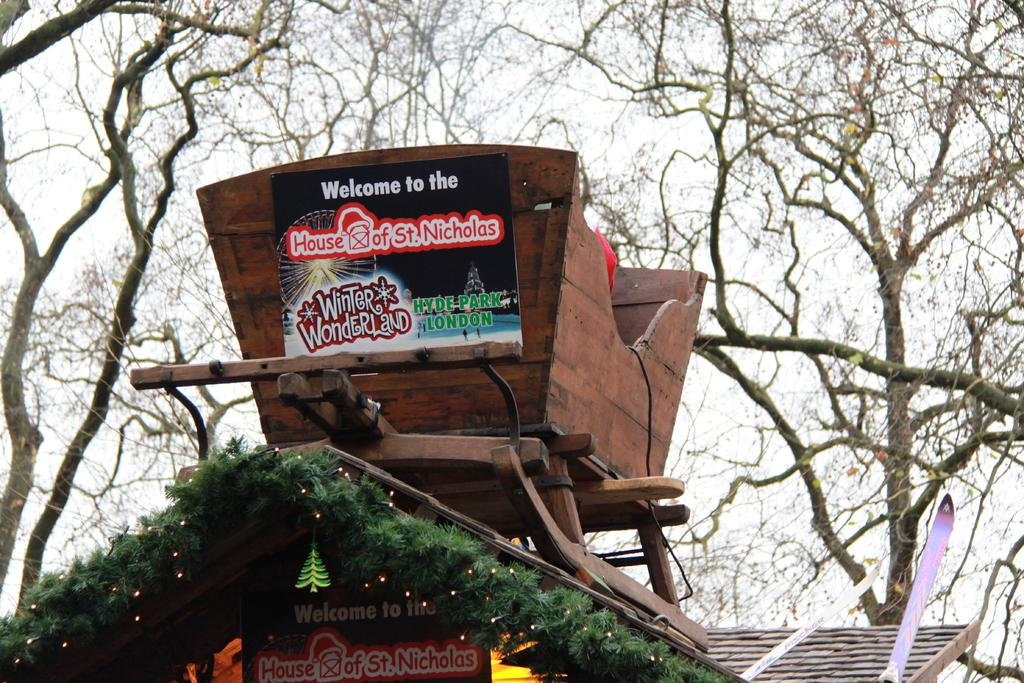What type of house is in the image? There is a wooden house in the image. What material is the house made of? The wooden house has boards. Is there any writing or text on the house? Yes, there is text on the boards of the wooden house. What can be seen in the background of the image? There are trees in the background of the image. What type of sail can be seen on the market in the image? There is no market or sail present in the image; it features a wooden house with text on the boards and trees in the background. 